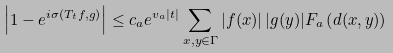Convert formula to latex. <formula><loc_0><loc_0><loc_500><loc_500>\left | 1 - e ^ { i \sigma ( T _ { t } f , g ) } \right | \leq c _ { a } e ^ { v _ { a } | t | } \sum _ { x , y \in \Gamma } | f ( x ) | \, | g ( y ) | F _ { a } \left ( d ( x , y ) \right )</formula> 